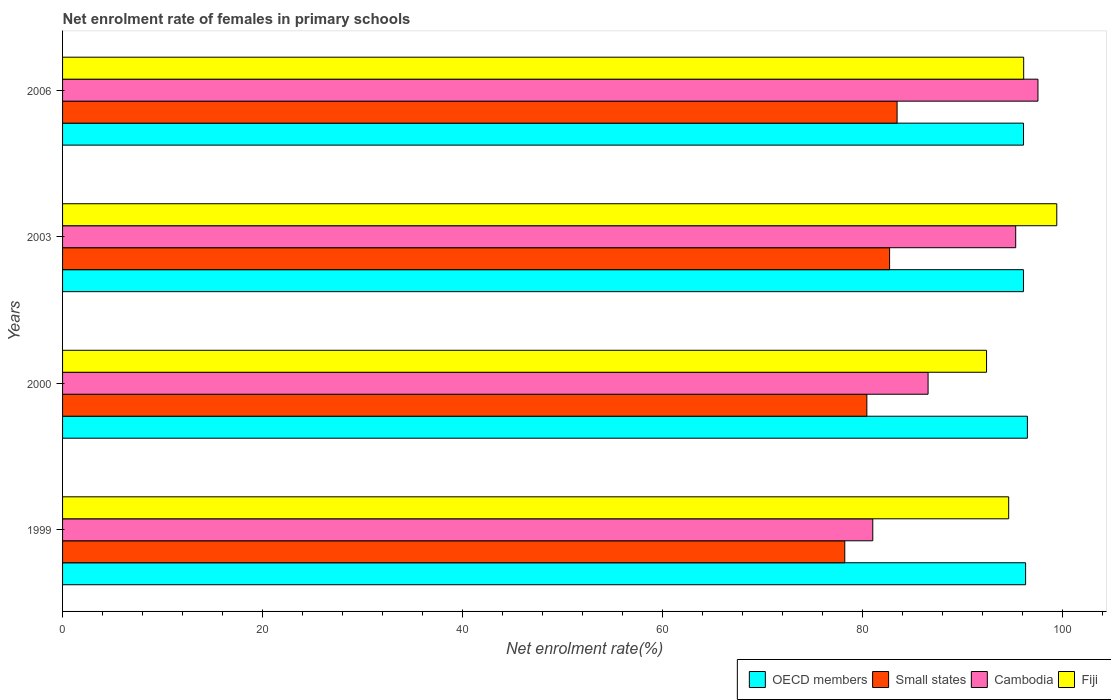How many different coloured bars are there?
Keep it short and to the point. 4. How many groups of bars are there?
Offer a very short reply. 4. How many bars are there on the 3rd tick from the top?
Offer a terse response. 4. How many bars are there on the 4th tick from the bottom?
Make the answer very short. 4. In how many cases, is the number of bars for a given year not equal to the number of legend labels?
Keep it short and to the point. 0. What is the net enrolment rate of females in primary schools in Small states in 2000?
Your answer should be compact. 80.4. Across all years, what is the maximum net enrolment rate of females in primary schools in Small states?
Keep it short and to the point. 83.42. Across all years, what is the minimum net enrolment rate of females in primary schools in Small states?
Your answer should be very brief. 78.19. In which year was the net enrolment rate of females in primary schools in Small states maximum?
Ensure brevity in your answer.  2006. In which year was the net enrolment rate of females in primary schools in Fiji minimum?
Offer a terse response. 2000. What is the total net enrolment rate of females in primary schools in Small states in the graph?
Your answer should be very brief. 324.68. What is the difference between the net enrolment rate of females in primary schools in Fiji in 1999 and that in 2003?
Make the answer very short. -4.81. What is the difference between the net enrolment rate of females in primary schools in OECD members in 2006 and the net enrolment rate of females in primary schools in Fiji in 2003?
Your answer should be compact. -3.32. What is the average net enrolment rate of females in primary schools in OECD members per year?
Keep it short and to the point. 96.21. In the year 2003, what is the difference between the net enrolment rate of females in primary schools in Cambodia and net enrolment rate of females in primary schools in Fiji?
Your answer should be compact. -4.11. What is the ratio of the net enrolment rate of females in primary schools in Fiji in 1999 to that in 2003?
Give a very brief answer. 0.95. Is the net enrolment rate of females in primary schools in Fiji in 1999 less than that in 2003?
Your answer should be very brief. Yes. Is the difference between the net enrolment rate of females in primary schools in Cambodia in 1999 and 2000 greater than the difference between the net enrolment rate of females in primary schools in Fiji in 1999 and 2000?
Your answer should be compact. No. What is the difference between the highest and the second highest net enrolment rate of females in primary schools in Small states?
Give a very brief answer. 0.75. What is the difference between the highest and the lowest net enrolment rate of females in primary schools in Fiji?
Offer a terse response. 7.02. In how many years, is the net enrolment rate of females in primary schools in Fiji greater than the average net enrolment rate of females in primary schools in Fiji taken over all years?
Provide a succinct answer. 2. Is the sum of the net enrolment rate of females in primary schools in OECD members in 2003 and 2006 greater than the maximum net enrolment rate of females in primary schools in Cambodia across all years?
Give a very brief answer. Yes. Is it the case that in every year, the sum of the net enrolment rate of females in primary schools in Fiji and net enrolment rate of females in primary schools in Small states is greater than the sum of net enrolment rate of females in primary schools in Cambodia and net enrolment rate of females in primary schools in OECD members?
Your answer should be compact. No. What does the 4th bar from the top in 1999 represents?
Provide a short and direct response. OECD members. What does the 3rd bar from the bottom in 1999 represents?
Ensure brevity in your answer.  Cambodia. How many years are there in the graph?
Your answer should be compact. 4. Does the graph contain any zero values?
Ensure brevity in your answer.  No. How many legend labels are there?
Your answer should be compact. 4. What is the title of the graph?
Make the answer very short. Net enrolment rate of females in primary schools. Does "Niger" appear as one of the legend labels in the graph?
Give a very brief answer. No. What is the label or title of the X-axis?
Your response must be concise. Net enrolment rate(%). What is the Net enrolment rate(%) in OECD members in 1999?
Keep it short and to the point. 96.27. What is the Net enrolment rate(%) of Small states in 1999?
Your answer should be very brief. 78.19. What is the Net enrolment rate(%) of Cambodia in 1999?
Your answer should be compact. 80.99. What is the Net enrolment rate(%) of Fiji in 1999?
Your response must be concise. 94.58. What is the Net enrolment rate(%) of OECD members in 2000?
Your answer should be very brief. 96.45. What is the Net enrolment rate(%) of Small states in 2000?
Offer a very short reply. 80.4. What is the Net enrolment rate(%) of Cambodia in 2000?
Your answer should be very brief. 86.52. What is the Net enrolment rate(%) of Fiji in 2000?
Offer a terse response. 92.36. What is the Net enrolment rate(%) in OECD members in 2003?
Your answer should be very brief. 96.05. What is the Net enrolment rate(%) of Small states in 2003?
Keep it short and to the point. 82.67. What is the Net enrolment rate(%) in Cambodia in 2003?
Your answer should be compact. 95.28. What is the Net enrolment rate(%) in Fiji in 2003?
Ensure brevity in your answer.  99.38. What is the Net enrolment rate(%) of OECD members in 2006?
Give a very brief answer. 96.06. What is the Net enrolment rate(%) of Small states in 2006?
Make the answer very short. 83.42. What is the Net enrolment rate(%) in Cambodia in 2006?
Provide a succinct answer. 97.5. What is the Net enrolment rate(%) of Fiji in 2006?
Offer a terse response. 96.07. Across all years, what is the maximum Net enrolment rate(%) in OECD members?
Your response must be concise. 96.45. Across all years, what is the maximum Net enrolment rate(%) of Small states?
Ensure brevity in your answer.  83.42. Across all years, what is the maximum Net enrolment rate(%) of Cambodia?
Your response must be concise. 97.5. Across all years, what is the maximum Net enrolment rate(%) of Fiji?
Offer a very short reply. 99.38. Across all years, what is the minimum Net enrolment rate(%) of OECD members?
Offer a very short reply. 96.05. Across all years, what is the minimum Net enrolment rate(%) in Small states?
Your response must be concise. 78.19. Across all years, what is the minimum Net enrolment rate(%) of Cambodia?
Offer a very short reply. 80.99. Across all years, what is the minimum Net enrolment rate(%) in Fiji?
Provide a succinct answer. 92.36. What is the total Net enrolment rate(%) in OECD members in the graph?
Your response must be concise. 384.83. What is the total Net enrolment rate(%) in Small states in the graph?
Provide a succinct answer. 324.68. What is the total Net enrolment rate(%) of Cambodia in the graph?
Ensure brevity in your answer.  360.29. What is the total Net enrolment rate(%) in Fiji in the graph?
Your response must be concise. 382.4. What is the difference between the Net enrolment rate(%) of OECD members in 1999 and that in 2000?
Ensure brevity in your answer.  -0.18. What is the difference between the Net enrolment rate(%) of Small states in 1999 and that in 2000?
Make the answer very short. -2.21. What is the difference between the Net enrolment rate(%) in Cambodia in 1999 and that in 2000?
Give a very brief answer. -5.53. What is the difference between the Net enrolment rate(%) in Fiji in 1999 and that in 2000?
Provide a short and direct response. 2.21. What is the difference between the Net enrolment rate(%) of OECD members in 1999 and that in 2003?
Keep it short and to the point. 0.21. What is the difference between the Net enrolment rate(%) in Small states in 1999 and that in 2003?
Make the answer very short. -4.48. What is the difference between the Net enrolment rate(%) in Cambodia in 1999 and that in 2003?
Give a very brief answer. -14.29. What is the difference between the Net enrolment rate(%) in Fiji in 1999 and that in 2003?
Give a very brief answer. -4.81. What is the difference between the Net enrolment rate(%) in OECD members in 1999 and that in 2006?
Ensure brevity in your answer.  0.21. What is the difference between the Net enrolment rate(%) in Small states in 1999 and that in 2006?
Offer a terse response. -5.23. What is the difference between the Net enrolment rate(%) of Cambodia in 1999 and that in 2006?
Offer a terse response. -16.51. What is the difference between the Net enrolment rate(%) in Fiji in 1999 and that in 2006?
Offer a very short reply. -1.5. What is the difference between the Net enrolment rate(%) in OECD members in 2000 and that in 2003?
Give a very brief answer. 0.39. What is the difference between the Net enrolment rate(%) of Small states in 2000 and that in 2003?
Provide a short and direct response. -2.27. What is the difference between the Net enrolment rate(%) of Cambodia in 2000 and that in 2003?
Give a very brief answer. -8.76. What is the difference between the Net enrolment rate(%) of Fiji in 2000 and that in 2003?
Provide a short and direct response. -7.02. What is the difference between the Net enrolment rate(%) of OECD members in 2000 and that in 2006?
Your answer should be very brief. 0.39. What is the difference between the Net enrolment rate(%) in Small states in 2000 and that in 2006?
Offer a terse response. -3.02. What is the difference between the Net enrolment rate(%) of Cambodia in 2000 and that in 2006?
Give a very brief answer. -10.98. What is the difference between the Net enrolment rate(%) in Fiji in 2000 and that in 2006?
Offer a very short reply. -3.71. What is the difference between the Net enrolment rate(%) in OECD members in 2003 and that in 2006?
Make the answer very short. -0.01. What is the difference between the Net enrolment rate(%) of Small states in 2003 and that in 2006?
Give a very brief answer. -0.75. What is the difference between the Net enrolment rate(%) in Cambodia in 2003 and that in 2006?
Your answer should be very brief. -2.22. What is the difference between the Net enrolment rate(%) of Fiji in 2003 and that in 2006?
Offer a very short reply. 3.31. What is the difference between the Net enrolment rate(%) in OECD members in 1999 and the Net enrolment rate(%) in Small states in 2000?
Keep it short and to the point. 15.87. What is the difference between the Net enrolment rate(%) in OECD members in 1999 and the Net enrolment rate(%) in Cambodia in 2000?
Provide a succinct answer. 9.75. What is the difference between the Net enrolment rate(%) of OECD members in 1999 and the Net enrolment rate(%) of Fiji in 2000?
Make the answer very short. 3.9. What is the difference between the Net enrolment rate(%) of Small states in 1999 and the Net enrolment rate(%) of Cambodia in 2000?
Your answer should be very brief. -8.33. What is the difference between the Net enrolment rate(%) in Small states in 1999 and the Net enrolment rate(%) in Fiji in 2000?
Give a very brief answer. -14.17. What is the difference between the Net enrolment rate(%) in Cambodia in 1999 and the Net enrolment rate(%) in Fiji in 2000?
Make the answer very short. -11.37. What is the difference between the Net enrolment rate(%) of OECD members in 1999 and the Net enrolment rate(%) of Small states in 2003?
Offer a very short reply. 13.6. What is the difference between the Net enrolment rate(%) of OECD members in 1999 and the Net enrolment rate(%) of Cambodia in 2003?
Your response must be concise. 0.99. What is the difference between the Net enrolment rate(%) of OECD members in 1999 and the Net enrolment rate(%) of Fiji in 2003?
Give a very brief answer. -3.12. What is the difference between the Net enrolment rate(%) of Small states in 1999 and the Net enrolment rate(%) of Cambodia in 2003?
Your response must be concise. -17.09. What is the difference between the Net enrolment rate(%) in Small states in 1999 and the Net enrolment rate(%) in Fiji in 2003?
Your answer should be compact. -21.19. What is the difference between the Net enrolment rate(%) of Cambodia in 1999 and the Net enrolment rate(%) of Fiji in 2003?
Your response must be concise. -18.39. What is the difference between the Net enrolment rate(%) of OECD members in 1999 and the Net enrolment rate(%) of Small states in 2006?
Offer a very short reply. 12.85. What is the difference between the Net enrolment rate(%) in OECD members in 1999 and the Net enrolment rate(%) in Cambodia in 2006?
Your answer should be very brief. -1.23. What is the difference between the Net enrolment rate(%) of OECD members in 1999 and the Net enrolment rate(%) of Fiji in 2006?
Your answer should be very brief. 0.19. What is the difference between the Net enrolment rate(%) in Small states in 1999 and the Net enrolment rate(%) in Cambodia in 2006?
Provide a short and direct response. -19.31. What is the difference between the Net enrolment rate(%) of Small states in 1999 and the Net enrolment rate(%) of Fiji in 2006?
Make the answer very short. -17.88. What is the difference between the Net enrolment rate(%) of Cambodia in 1999 and the Net enrolment rate(%) of Fiji in 2006?
Ensure brevity in your answer.  -15.08. What is the difference between the Net enrolment rate(%) of OECD members in 2000 and the Net enrolment rate(%) of Small states in 2003?
Keep it short and to the point. 13.78. What is the difference between the Net enrolment rate(%) of OECD members in 2000 and the Net enrolment rate(%) of Cambodia in 2003?
Provide a succinct answer. 1.17. What is the difference between the Net enrolment rate(%) of OECD members in 2000 and the Net enrolment rate(%) of Fiji in 2003?
Provide a short and direct response. -2.94. What is the difference between the Net enrolment rate(%) in Small states in 2000 and the Net enrolment rate(%) in Cambodia in 2003?
Provide a succinct answer. -14.88. What is the difference between the Net enrolment rate(%) in Small states in 2000 and the Net enrolment rate(%) in Fiji in 2003?
Your answer should be compact. -18.99. What is the difference between the Net enrolment rate(%) of Cambodia in 2000 and the Net enrolment rate(%) of Fiji in 2003?
Give a very brief answer. -12.87. What is the difference between the Net enrolment rate(%) of OECD members in 2000 and the Net enrolment rate(%) of Small states in 2006?
Provide a short and direct response. 13.03. What is the difference between the Net enrolment rate(%) in OECD members in 2000 and the Net enrolment rate(%) in Cambodia in 2006?
Provide a short and direct response. -1.06. What is the difference between the Net enrolment rate(%) in OECD members in 2000 and the Net enrolment rate(%) in Fiji in 2006?
Your response must be concise. 0.37. What is the difference between the Net enrolment rate(%) in Small states in 2000 and the Net enrolment rate(%) in Cambodia in 2006?
Your answer should be compact. -17.1. What is the difference between the Net enrolment rate(%) in Small states in 2000 and the Net enrolment rate(%) in Fiji in 2006?
Offer a terse response. -15.68. What is the difference between the Net enrolment rate(%) of Cambodia in 2000 and the Net enrolment rate(%) of Fiji in 2006?
Your answer should be very brief. -9.56. What is the difference between the Net enrolment rate(%) in OECD members in 2003 and the Net enrolment rate(%) in Small states in 2006?
Make the answer very short. 12.63. What is the difference between the Net enrolment rate(%) in OECD members in 2003 and the Net enrolment rate(%) in Cambodia in 2006?
Provide a short and direct response. -1.45. What is the difference between the Net enrolment rate(%) of OECD members in 2003 and the Net enrolment rate(%) of Fiji in 2006?
Provide a succinct answer. -0.02. What is the difference between the Net enrolment rate(%) of Small states in 2003 and the Net enrolment rate(%) of Cambodia in 2006?
Your answer should be very brief. -14.83. What is the difference between the Net enrolment rate(%) of Small states in 2003 and the Net enrolment rate(%) of Fiji in 2006?
Your answer should be very brief. -13.4. What is the difference between the Net enrolment rate(%) in Cambodia in 2003 and the Net enrolment rate(%) in Fiji in 2006?
Offer a terse response. -0.8. What is the average Net enrolment rate(%) in OECD members per year?
Provide a succinct answer. 96.21. What is the average Net enrolment rate(%) of Small states per year?
Your answer should be very brief. 81.17. What is the average Net enrolment rate(%) of Cambodia per year?
Offer a terse response. 90.07. What is the average Net enrolment rate(%) of Fiji per year?
Give a very brief answer. 95.6. In the year 1999, what is the difference between the Net enrolment rate(%) of OECD members and Net enrolment rate(%) of Small states?
Offer a terse response. 18.08. In the year 1999, what is the difference between the Net enrolment rate(%) of OECD members and Net enrolment rate(%) of Cambodia?
Provide a succinct answer. 15.28. In the year 1999, what is the difference between the Net enrolment rate(%) in OECD members and Net enrolment rate(%) in Fiji?
Keep it short and to the point. 1.69. In the year 1999, what is the difference between the Net enrolment rate(%) in Small states and Net enrolment rate(%) in Cambodia?
Your answer should be very brief. -2.8. In the year 1999, what is the difference between the Net enrolment rate(%) in Small states and Net enrolment rate(%) in Fiji?
Offer a very short reply. -16.38. In the year 1999, what is the difference between the Net enrolment rate(%) in Cambodia and Net enrolment rate(%) in Fiji?
Ensure brevity in your answer.  -13.58. In the year 2000, what is the difference between the Net enrolment rate(%) of OECD members and Net enrolment rate(%) of Small states?
Offer a terse response. 16.05. In the year 2000, what is the difference between the Net enrolment rate(%) in OECD members and Net enrolment rate(%) in Cambodia?
Offer a terse response. 9.93. In the year 2000, what is the difference between the Net enrolment rate(%) of OECD members and Net enrolment rate(%) of Fiji?
Offer a terse response. 4.08. In the year 2000, what is the difference between the Net enrolment rate(%) in Small states and Net enrolment rate(%) in Cambodia?
Offer a terse response. -6.12. In the year 2000, what is the difference between the Net enrolment rate(%) of Small states and Net enrolment rate(%) of Fiji?
Provide a short and direct response. -11.97. In the year 2000, what is the difference between the Net enrolment rate(%) of Cambodia and Net enrolment rate(%) of Fiji?
Offer a terse response. -5.85. In the year 2003, what is the difference between the Net enrolment rate(%) in OECD members and Net enrolment rate(%) in Small states?
Your answer should be compact. 13.38. In the year 2003, what is the difference between the Net enrolment rate(%) of OECD members and Net enrolment rate(%) of Cambodia?
Offer a terse response. 0.78. In the year 2003, what is the difference between the Net enrolment rate(%) of OECD members and Net enrolment rate(%) of Fiji?
Provide a succinct answer. -3.33. In the year 2003, what is the difference between the Net enrolment rate(%) of Small states and Net enrolment rate(%) of Cambodia?
Give a very brief answer. -12.61. In the year 2003, what is the difference between the Net enrolment rate(%) in Small states and Net enrolment rate(%) in Fiji?
Offer a terse response. -16.71. In the year 2003, what is the difference between the Net enrolment rate(%) in Cambodia and Net enrolment rate(%) in Fiji?
Provide a succinct answer. -4.11. In the year 2006, what is the difference between the Net enrolment rate(%) of OECD members and Net enrolment rate(%) of Small states?
Ensure brevity in your answer.  12.64. In the year 2006, what is the difference between the Net enrolment rate(%) of OECD members and Net enrolment rate(%) of Cambodia?
Ensure brevity in your answer.  -1.44. In the year 2006, what is the difference between the Net enrolment rate(%) in OECD members and Net enrolment rate(%) in Fiji?
Provide a succinct answer. -0.01. In the year 2006, what is the difference between the Net enrolment rate(%) in Small states and Net enrolment rate(%) in Cambodia?
Ensure brevity in your answer.  -14.08. In the year 2006, what is the difference between the Net enrolment rate(%) in Small states and Net enrolment rate(%) in Fiji?
Your response must be concise. -12.65. In the year 2006, what is the difference between the Net enrolment rate(%) in Cambodia and Net enrolment rate(%) in Fiji?
Your response must be concise. 1.43. What is the ratio of the Net enrolment rate(%) of OECD members in 1999 to that in 2000?
Provide a short and direct response. 1. What is the ratio of the Net enrolment rate(%) in Small states in 1999 to that in 2000?
Keep it short and to the point. 0.97. What is the ratio of the Net enrolment rate(%) in Cambodia in 1999 to that in 2000?
Make the answer very short. 0.94. What is the ratio of the Net enrolment rate(%) of Fiji in 1999 to that in 2000?
Your answer should be compact. 1.02. What is the ratio of the Net enrolment rate(%) in Small states in 1999 to that in 2003?
Your response must be concise. 0.95. What is the ratio of the Net enrolment rate(%) in Cambodia in 1999 to that in 2003?
Offer a terse response. 0.85. What is the ratio of the Net enrolment rate(%) in Fiji in 1999 to that in 2003?
Your response must be concise. 0.95. What is the ratio of the Net enrolment rate(%) in OECD members in 1999 to that in 2006?
Provide a short and direct response. 1. What is the ratio of the Net enrolment rate(%) of Small states in 1999 to that in 2006?
Offer a very short reply. 0.94. What is the ratio of the Net enrolment rate(%) of Cambodia in 1999 to that in 2006?
Provide a succinct answer. 0.83. What is the ratio of the Net enrolment rate(%) of Fiji in 1999 to that in 2006?
Provide a short and direct response. 0.98. What is the ratio of the Net enrolment rate(%) of Small states in 2000 to that in 2003?
Offer a terse response. 0.97. What is the ratio of the Net enrolment rate(%) of Cambodia in 2000 to that in 2003?
Your answer should be compact. 0.91. What is the ratio of the Net enrolment rate(%) in Fiji in 2000 to that in 2003?
Ensure brevity in your answer.  0.93. What is the ratio of the Net enrolment rate(%) in Small states in 2000 to that in 2006?
Provide a short and direct response. 0.96. What is the ratio of the Net enrolment rate(%) of Cambodia in 2000 to that in 2006?
Make the answer very short. 0.89. What is the ratio of the Net enrolment rate(%) of Fiji in 2000 to that in 2006?
Ensure brevity in your answer.  0.96. What is the ratio of the Net enrolment rate(%) of OECD members in 2003 to that in 2006?
Provide a short and direct response. 1. What is the ratio of the Net enrolment rate(%) in Small states in 2003 to that in 2006?
Keep it short and to the point. 0.99. What is the ratio of the Net enrolment rate(%) in Cambodia in 2003 to that in 2006?
Ensure brevity in your answer.  0.98. What is the ratio of the Net enrolment rate(%) in Fiji in 2003 to that in 2006?
Offer a terse response. 1.03. What is the difference between the highest and the second highest Net enrolment rate(%) in OECD members?
Offer a very short reply. 0.18. What is the difference between the highest and the second highest Net enrolment rate(%) of Small states?
Provide a succinct answer. 0.75. What is the difference between the highest and the second highest Net enrolment rate(%) of Cambodia?
Give a very brief answer. 2.22. What is the difference between the highest and the second highest Net enrolment rate(%) in Fiji?
Ensure brevity in your answer.  3.31. What is the difference between the highest and the lowest Net enrolment rate(%) of OECD members?
Keep it short and to the point. 0.39. What is the difference between the highest and the lowest Net enrolment rate(%) in Small states?
Offer a very short reply. 5.23. What is the difference between the highest and the lowest Net enrolment rate(%) of Cambodia?
Your answer should be very brief. 16.51. What is the difference between the highest and the lowest Net enrolment rate(%) in Fiji?
Offer a terse response. 7.02. 